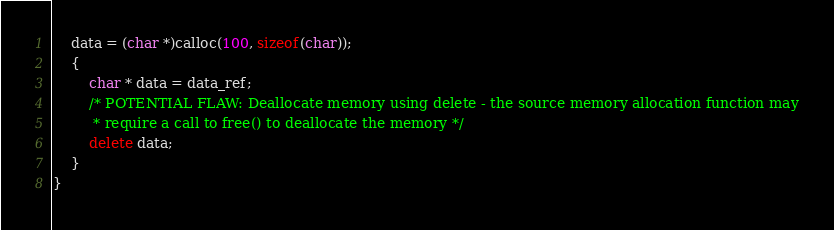Convert code to text. <code><loc_0><loc_0><loc_500><loc_500><_C++_>    data = (char *)calloc(100, sizeof(char));
    {
        char * data = data_ref;
        /* POTENTIAL FLAW: Deallocate memory using delete - the source memory allocation function may
         * require a call to free() to deallocate the memory */
        delete data;
    }
}
</code> 